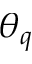<formula> <loc_0><loc_0><loc_500><loc_500>\theta _ { q }</formula> 